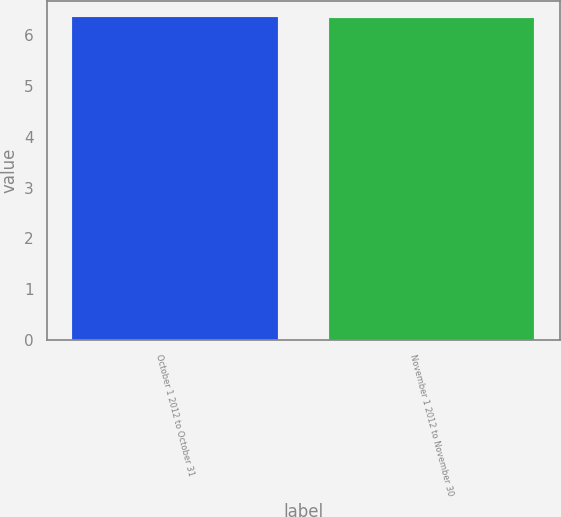Convert chart. <chart><loc_0><loc_0><loc_500><loc_500><bar_chart><fcel>October 1 2012 to October 31<fcel>November 1 2012 to November 30<nl><fcel>6.36<fcel>6.33<nl></chart> 